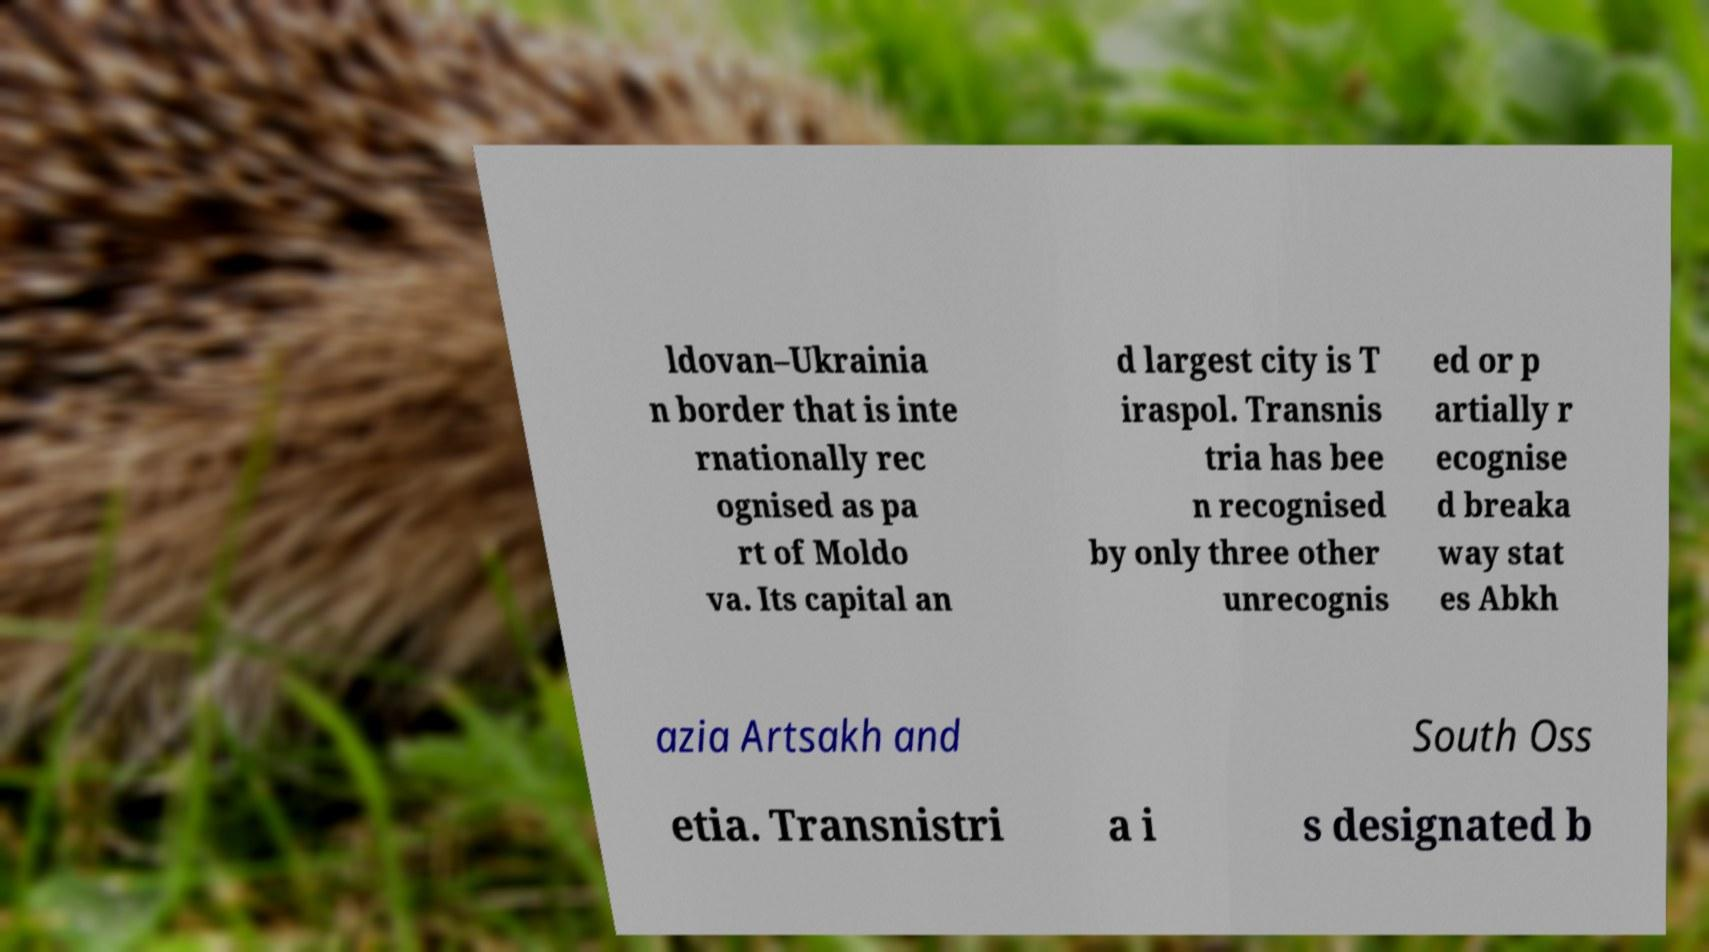There's text embedded in this image that I need extracted. Can you transcribe it verbatim? ldovan–Ukrainia n border that is inte rnationally rec ognised as pa rt of Moldo va. Its capital an d largest city is T iraspol. Transnis tria has bee n recognised by only three other unrecognis ed or p artially r ecognise d breaka way stat es Abkh azia Artsakh and South Oss etia. Transnistri a i s designated b 